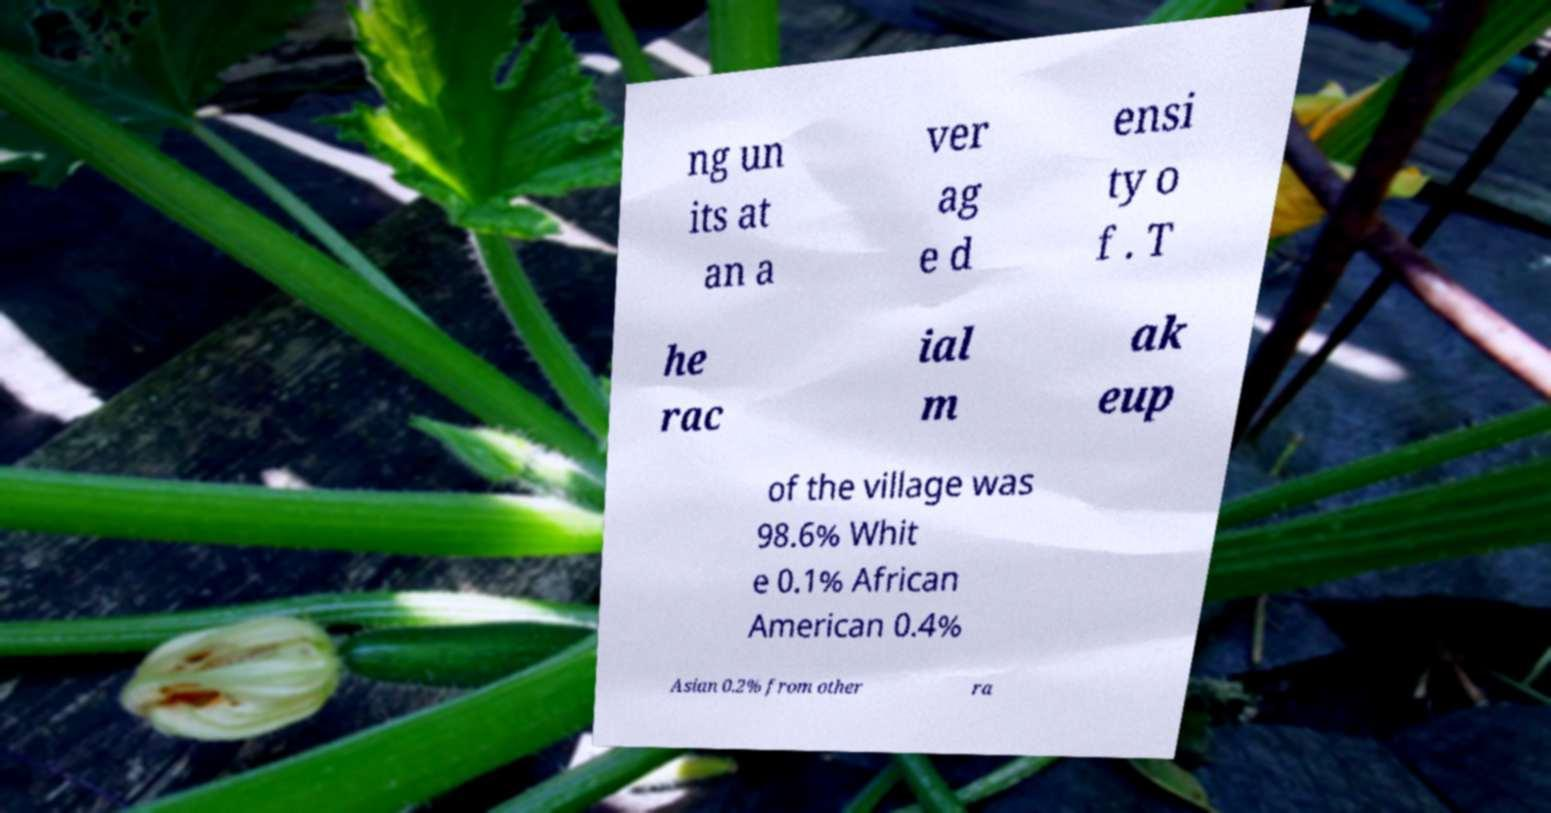What messages or text are displayed in this image? I need them in a readable, typed format. ng un its at an a ver ag e d ensi ty o f . T he rac ial m ak eup of the village was 98.6% Whit e 0.1% African American 0.4% Asian 0.2% from other ra 